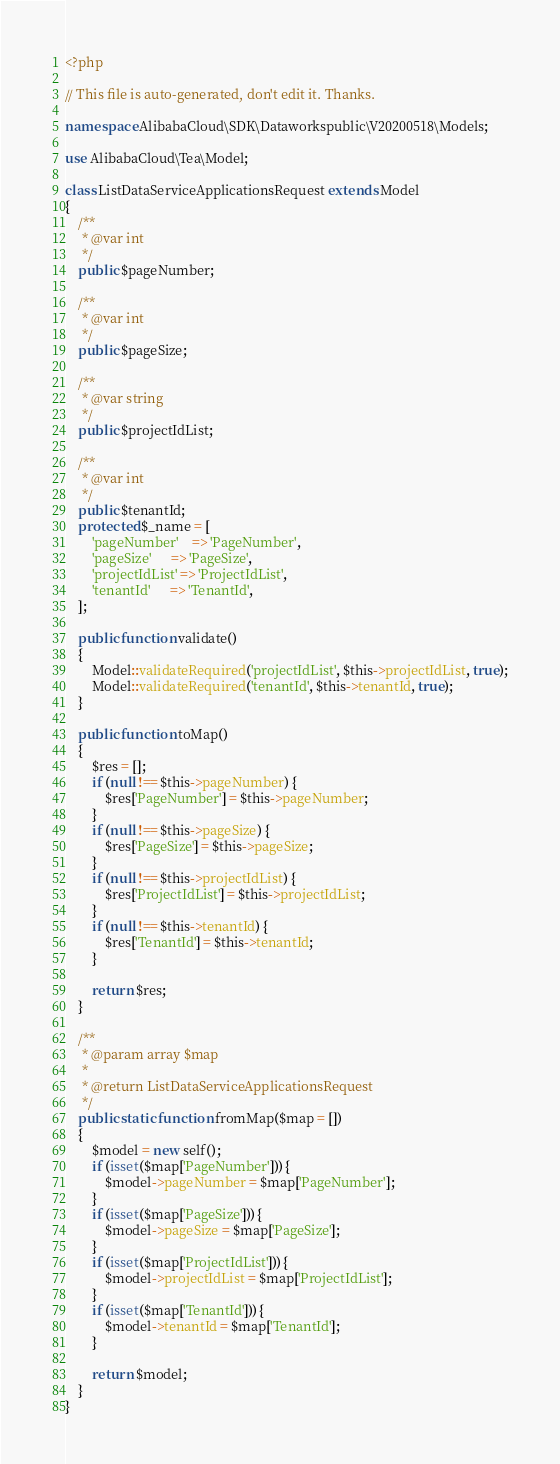<code> <loc_0><loc_0><loc_500><loc_500><_PHP_><?php

// This file is auto-generated, don't edit it. Thanks.

namespace AlibabaCloud\SDK\Dataworkspublic\V20200518\Models;

use AlibabaCloud\Tea\Model;

class ListDataServiceApplicationsRequest extends Model
{
    /**
     * @var int
     */
    public $pageNumber;

    /**
     * @var int
     */
    public $pageSize;

    /**
     * @var string
     */
    public $projectIdList;

    /**
     * @var int
     */
    public $tenantId;
    protected $_name = [
        'pageNumber'    => 'PageNumber',
        'pageSize'      => 'PageSize',
        'projectIdList' => 'ProjectIdList',
        'tenantId'      => 'TenantId',
    ];

    public function validate()
    {
        Model::validateRequired('projectIdList', $this->projectIdList, true);
        Model::validateRequired('tenantId', $this->tenantId, true);
    }

    public function toMap()
    {
        $res = [];
        if (null !== $this->pageNumber) {
            $res['PageNumber'] = $this->pageNumber;
        }
        if (null !== $this->pageSize) {
            $res['PageSize'] = $this->pageSize;
        }
        if (null !== $this->projectIdList) {
            $res['ProjectIdList'] = $this->projectIdList;
        }
        if (null !== $this->tenantId) {
            $res['TenantId'] = $this->tenantId;
        }

        return $res;
    }

    /**
     * @param array $map
     *
     * @return ListDataServiceApplicationsRequest
     */
    public static function fromMap($map = [])
    {
        $model = new self();
        if (isset($map['PageNumber'])) {
            $model->pageNumber = $map['PageNumber'];
        }
        if (isset($map['PageSize'])) {
            $model->pageSize = $map['PageSize'];
        }
        if (isset($map['ProjectIdList'])) {
            $model->projectIdList = $map['ProjectIdList'];
        }
        if (isset($map['TenantId'])) {
            $model->tenantId = $map['TenantId'];
        }

        return $model;
    }
}
</code> 